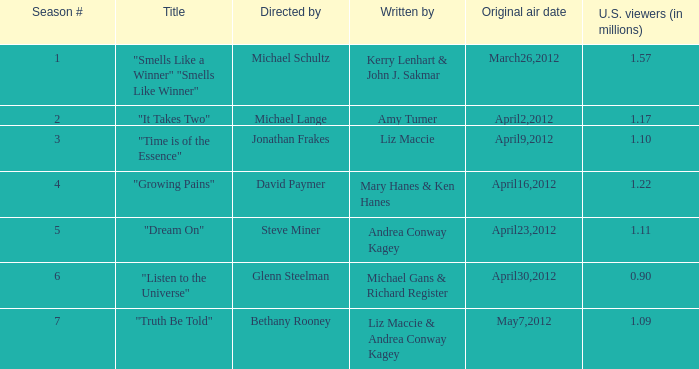What are the titles of the episodes which had 1.10 million U.S. viewers? "Time is of the Essence". 